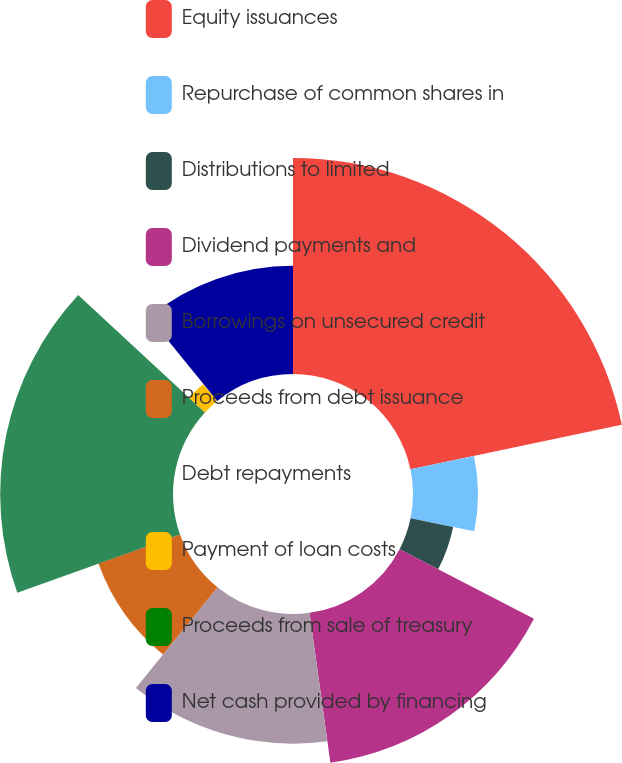Convert chart to OTSL. <chart><loc_0><loc_0><loc_500><loc_500><pie_chart><fcel>Equity issuances<fcel>Repurchase of common shares in<fcel>Distributions to limited<fcel>Dividend payments and<fcel>Borrowings on unsecured credit<fcel>Proceeds from debt issuance<fcel>Debt repayments<fcel>Payment of loan costs<fcel>Proceeds from sale of treasury<fcel>Net cash provided by financing<nl><fcel>21.7%<fcel>6.53%<fcel>4.37%<fcel>15.2%<fcel>13.03%<fcel>8.7%<fcel>17.36%<fcel>2.2%<fcel>0.04%<fcel>10.87%<nl></chart> 